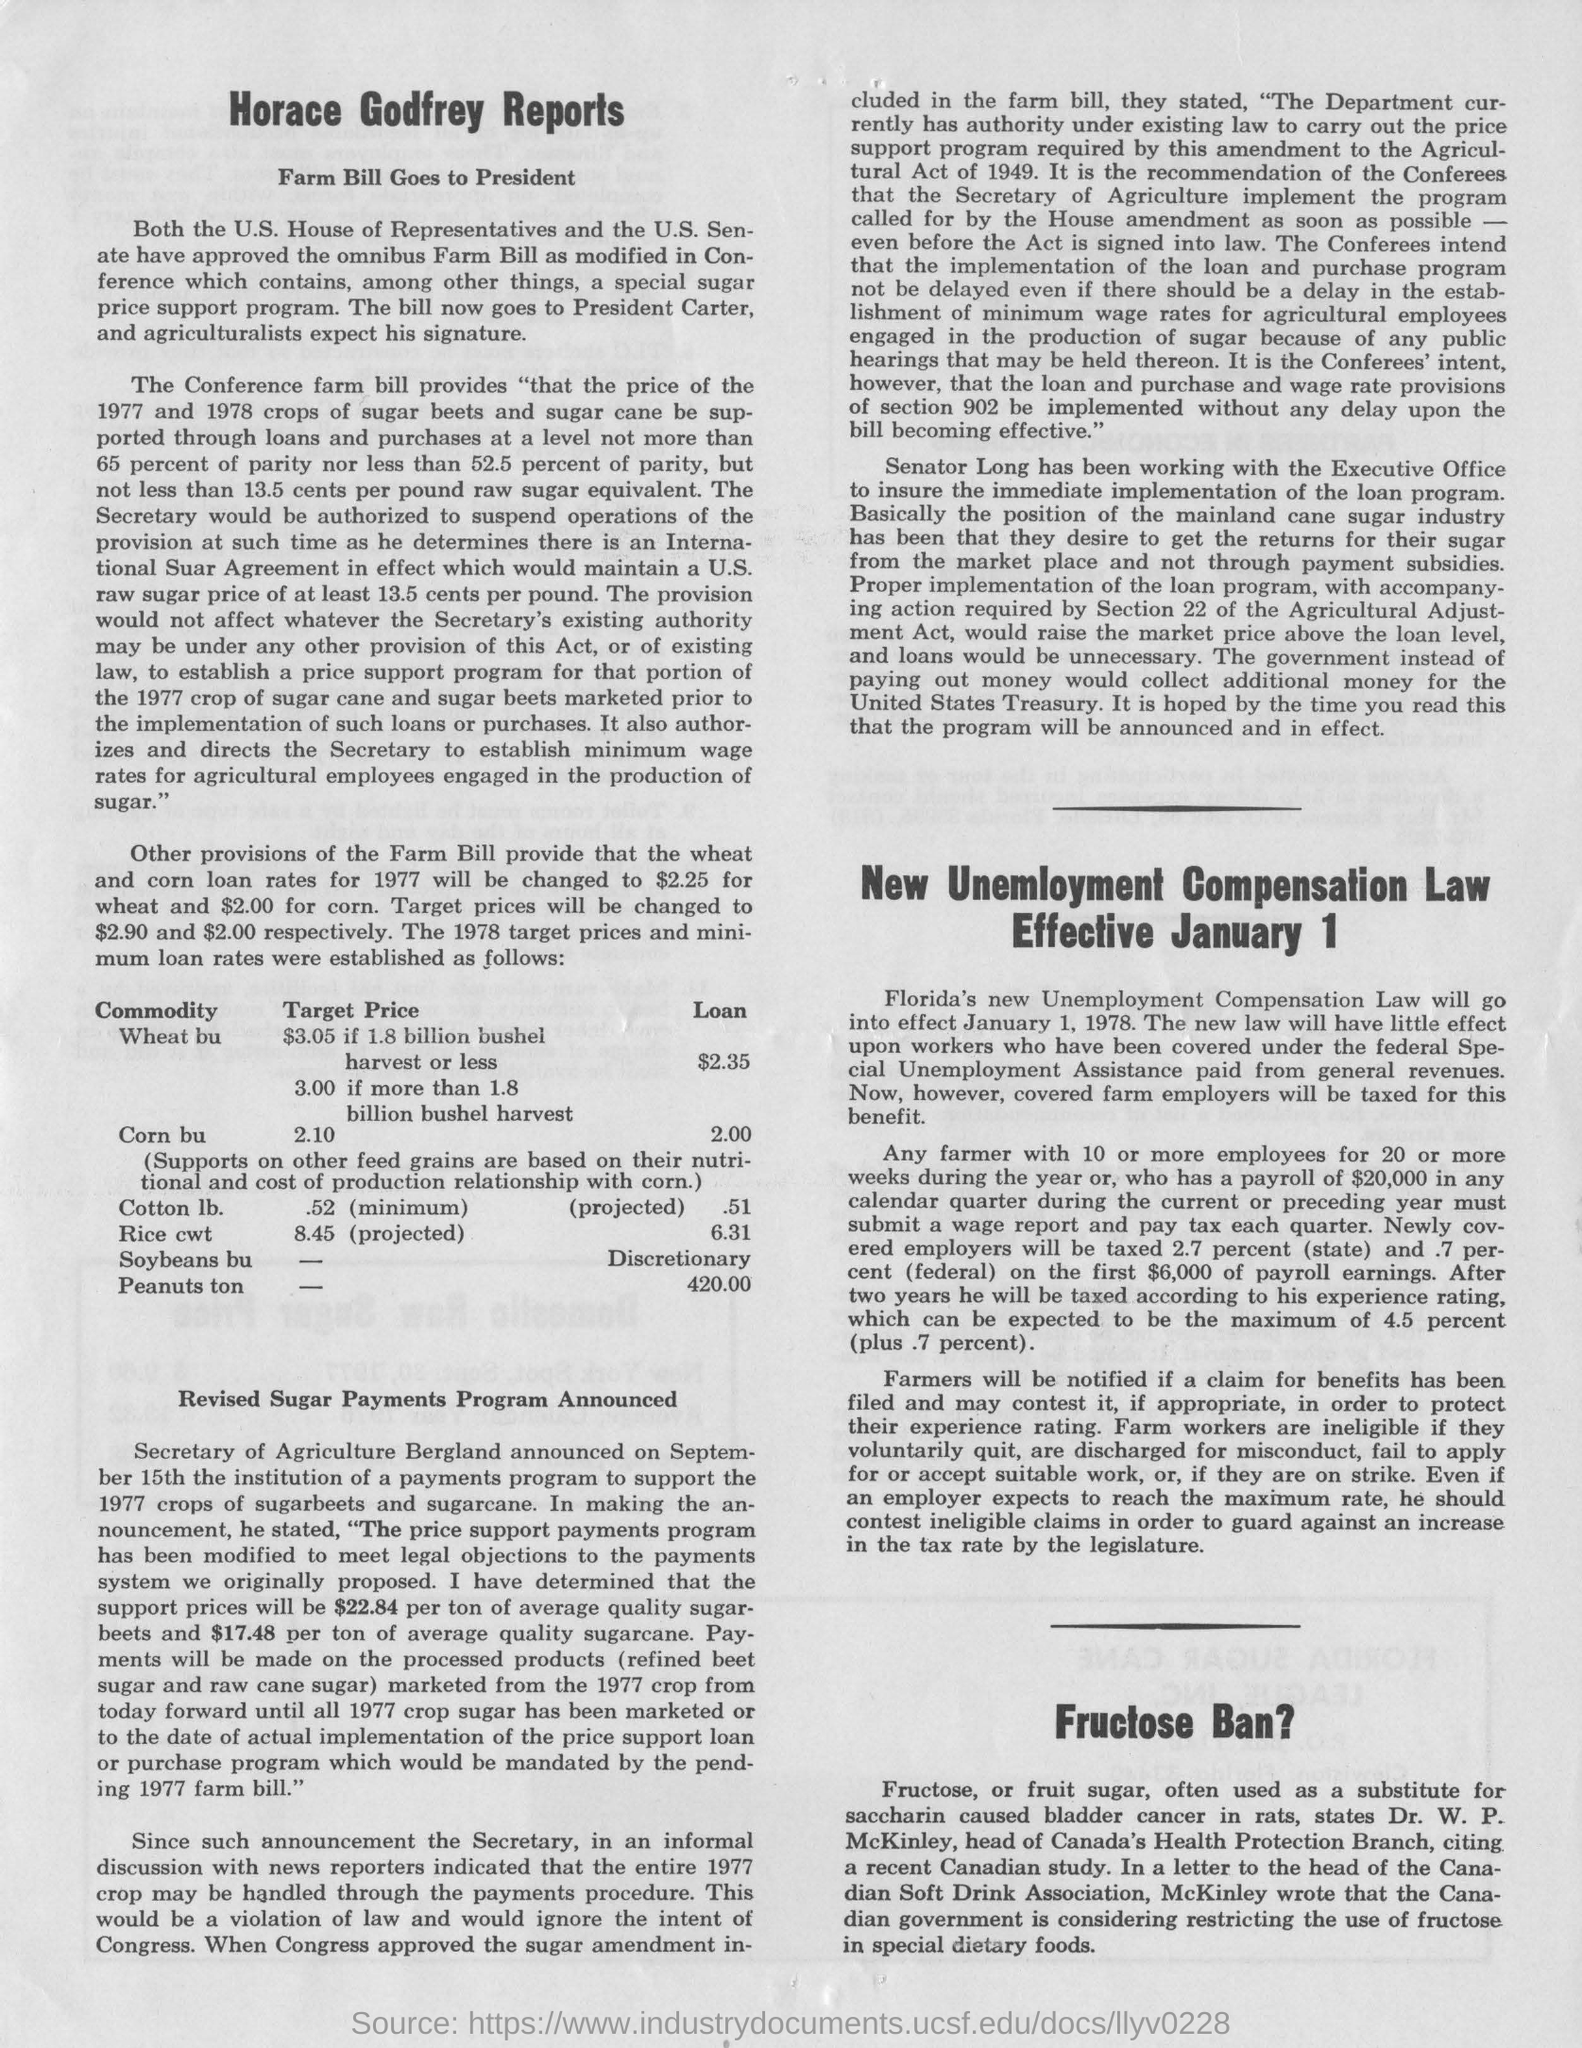Specify some key components in this picture. Fructose is commonly used as a substitute for saccharin. Dr. W. P. McKinley is the head of Canada's Health Protection Branch. 